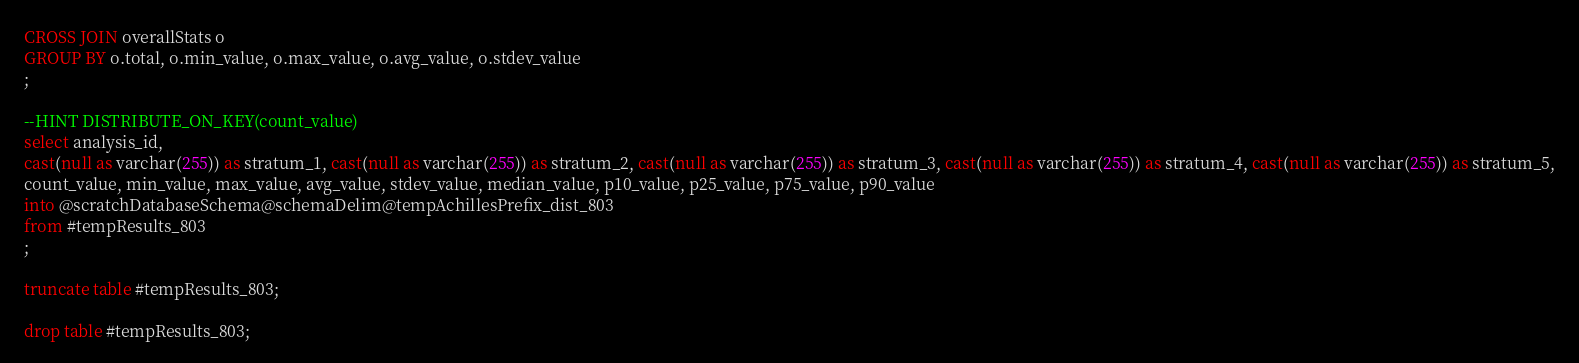<code> <loc_0><loc_0><loc_500><loc_500><_SQL_>CROSS JOIN overallStats o
GROUP BY o.total, o.min_value, o.max_value, o.avg_value, o.stdev_value
;

--HINT DISTRIBUTE_ON_KEY(count_value)
select analysis_id, 
cast(null as varchar(255)) as stratum_1, cast(null as varchar(255)) as stratum_2, cast(null as varchar(255)) as stratum_3, cast(null as varchar(255)) as stratum_4, cast(null as varchar(255)) as stratum_5,
count_value, min_value, max_value, avg_value, stdev_value, median_value, p10_value, p25_value, p75_value, p90_value
into @scratchDatabaseSchema@schemaDelim@tempAchillesPrefix_dist_803
from #tempResults_803
;

truncate table #tempResults_803;

drop table #tempResults_803;
</code> 